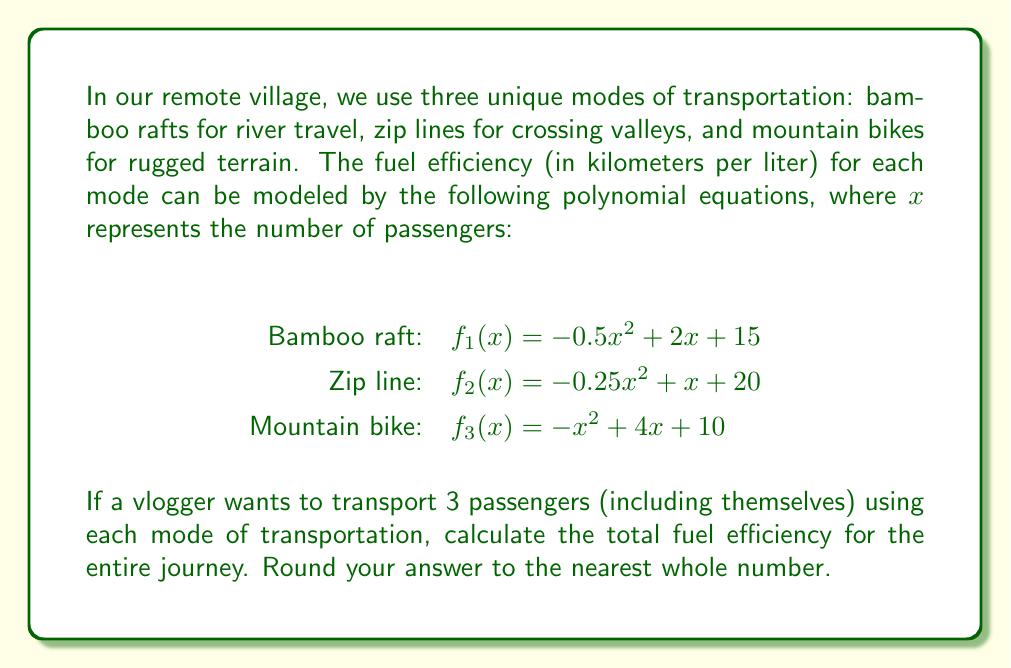Can you solve this math problem? To solve this problem, we need to follow these steps:

1) Substitute $x = 3$ into each polynomial equation to find the fuel efficiency for each mode of transportation with 3 passengers.

2) Add the results to get the total fuel efficiency.

3) Round the final answer to the nearest whole number.

Let's calculate:

1) For the bamboo raft:
   $f_1(3) = -0.5(3)^2 + 2(3) + 15$
   $= -0.5(9) + 6 + 15$
   $= -4.5 + 21$
   $= 16.5$ km/L

2) For the zip line:
   $f_2(3) = -0.25(3)^2 + 1(3) + 20$
   $= -0.25(9) + 3 + 20$
   $= -2.25 + 23$
   $= 20.75$ km/L

3) For the mountain bike:
   $f_3(3) = -(3)^2 + 4(3) + 10$
   $= -9 + 12 + 10$
   $= 13$ km/L

Now, let's add these results:

$16.5 + 20.75 + 13 = 50.25$ km/L

Rounding to the nearest whole number:

$50.25 \approx 50$ km/L
Answer: 50 km/L 